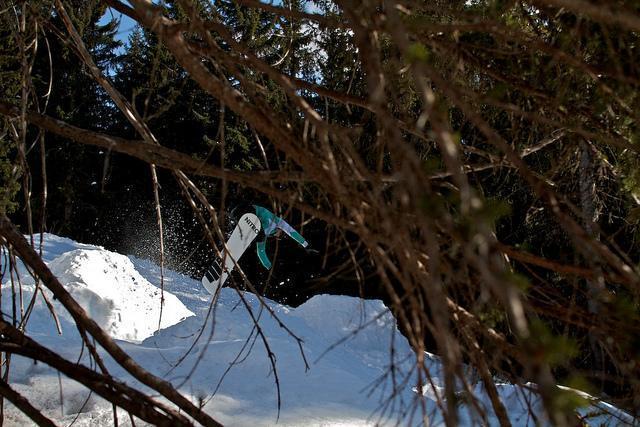How many chairs are there?
Give a very brief answer. 0. 